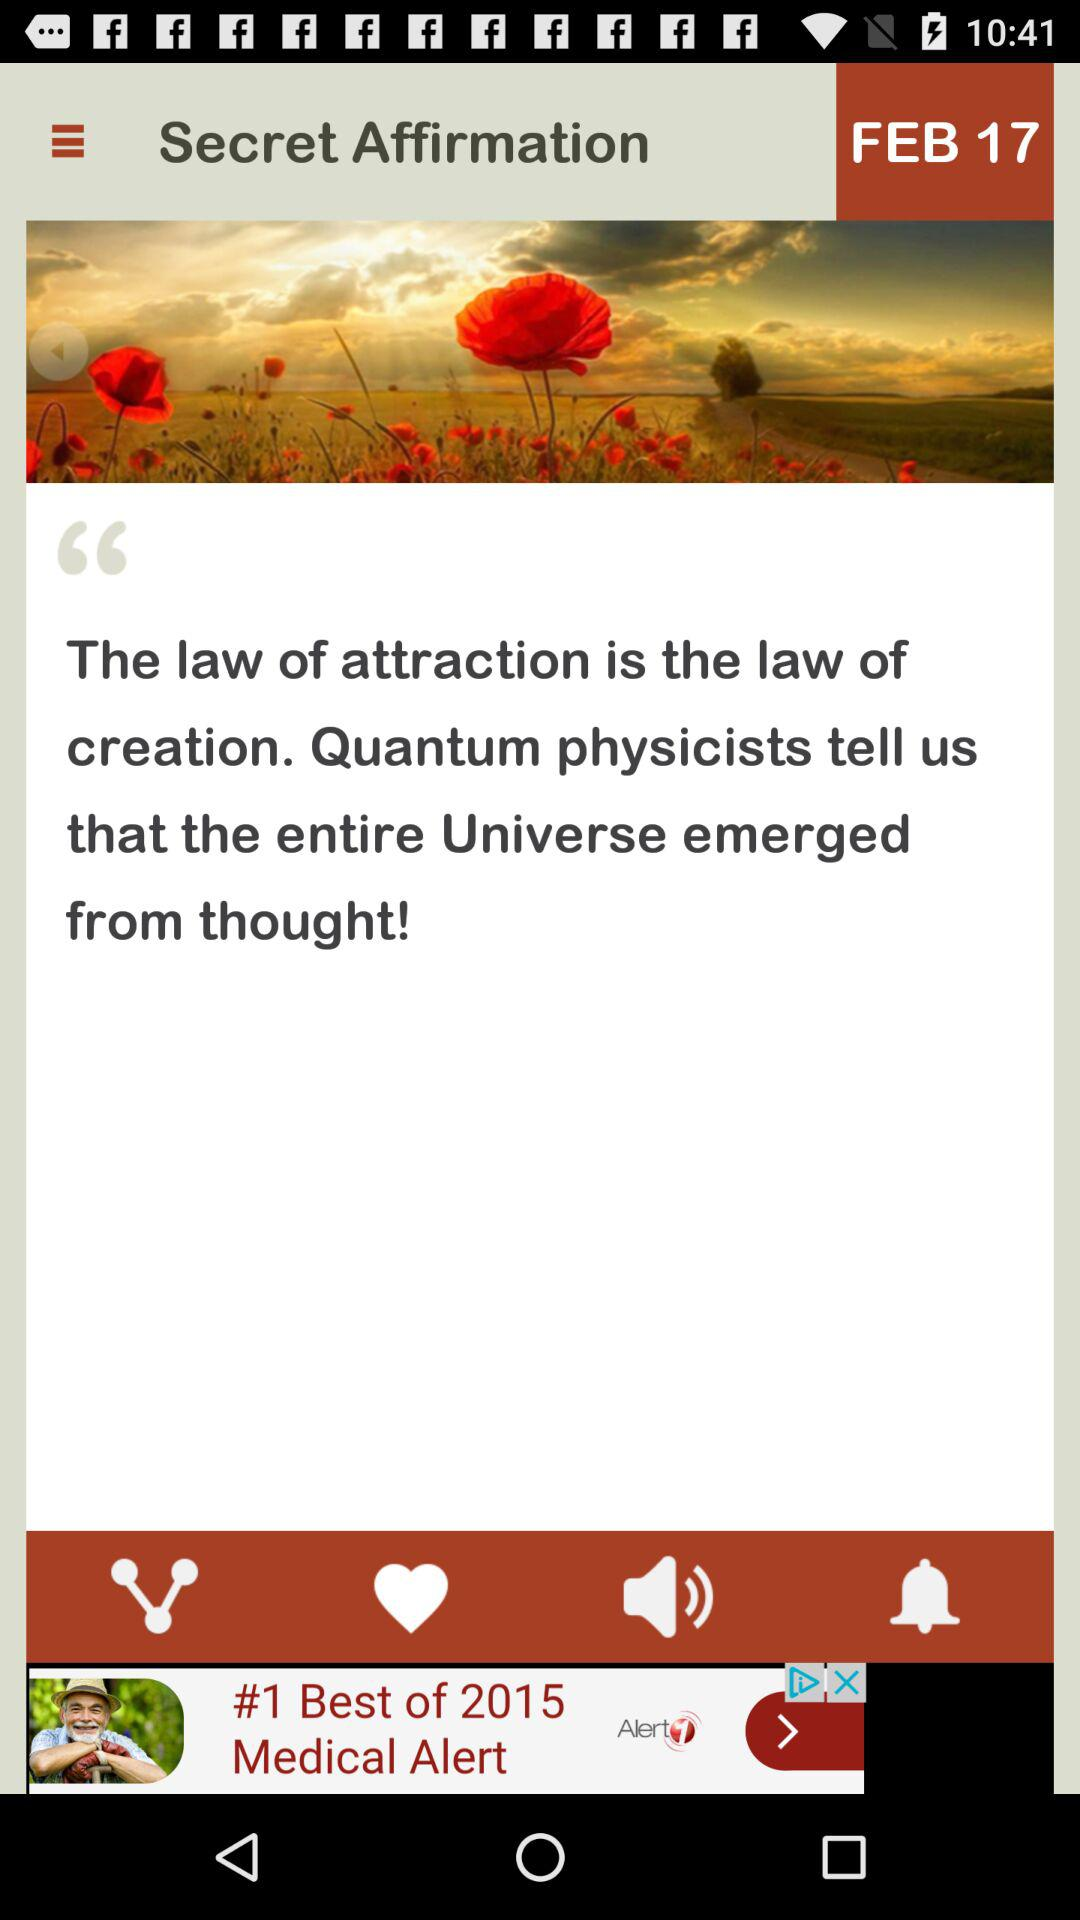What is the date? The date is February 17. 